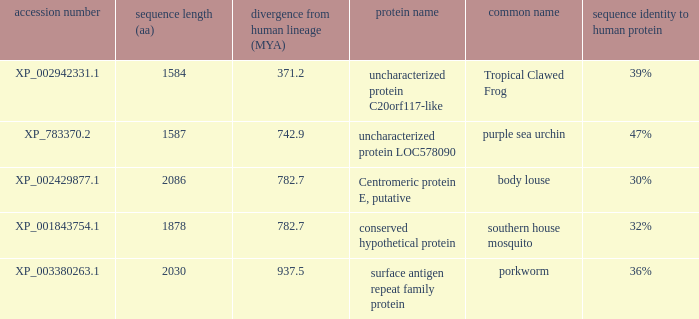What is the sequence length (aa) of the protein with the common name Purple Sea Urchin and a divergence from human lineage less than 742.9? None. 